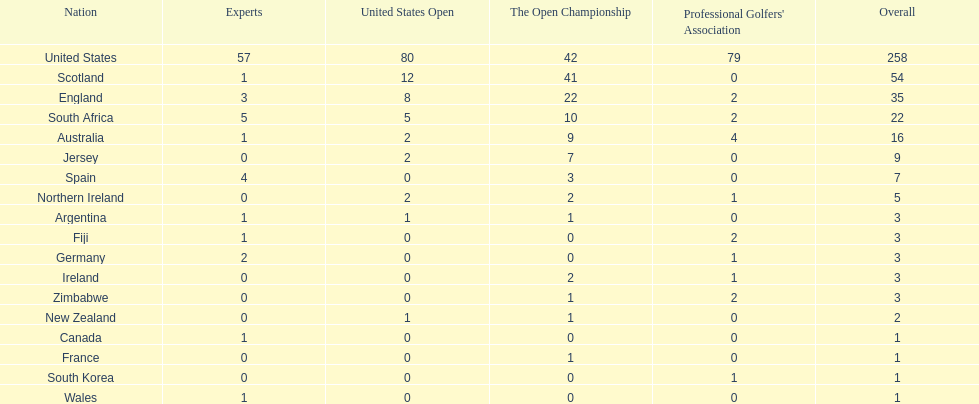Which african country has the least champion golfers according to this table? Zimbabwe. Would you be able to parse every entry in this table? {'header': ['Nation', 'Experts', 'United States Open', 'The Open Championship', "Professional Golfers' Association", 'Overall'], 'rows': [['United States', '57', '80', '42', '79', '258'], ['Scotland', '1', '12', '41', '0', '54'], ['England', '3', '8', '22', '2', '35'], ['South Africa', '5', '5', '10', '2', '22'], ['Australia', '1', '2', '9', '4', '16'], ['Jersey', '0', '2', '7', '0', '9'], ['Spain', '4', '0', '3', '0', '7'], ['Northern Ireland', '0', '2', '2', '1', '5'], ['Argentina', '1', '1', '1', '0', '3'], ['Fiji', '1', '0', '0', '2', '3'], ['Germany', '2', '0', '0', '1', '3'], ['Ireland', '0', '0', '2', '1', '3'], ['Zimbabwe', '0', '0', '1', '2', '3'], ['New Zealand', '0', '1', '1', '0', '2'], ['Canada', '1', '0', '0', '0', '1'], ['France', '0', '0', '1', '0', '1'], ['South Korea', '0', '0', '0', '1', '1'], ['Wales', '1', '0', '0', '0', '1']]} 